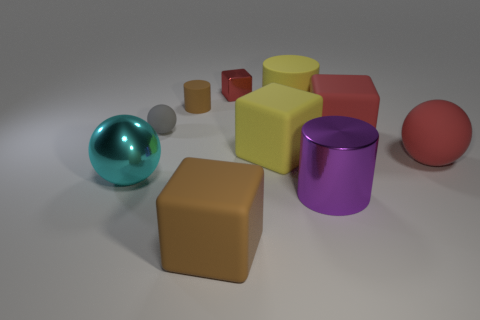Does the tiny metallic object have the same color as the big block right of the big rubber cylinder?
Offer a very short reply. Yes. Is there a cylinder that has the same material as the tiny red thing?
Your answer should be compact. Yes. The other rubber thing that is the same shape as the tiny brown object is what color?
Your answer should be compact. Yellow. Is the number of gray rubber objects in front of the red matte cube less than the number of rubber blocks to the right of the large purple metal cylinder?
Your response must be concise. Yes. How many other objects are there of the same shape as the cyan thing?
Give a very brief answer. 2. Is the number of shiny objects that are on the left side of the big metal cylinder less than the number of big things?
Your response must be concise. Yes. There is a big cylinder that is behind the large metallic cylinder; what material is it?
Keep it short and to the point. Rubber. What number of other things are there of the same size as the metal cylinder?
Provide a short and direct response. 6. Is the number of cyan rubber cylinders less than the number of big yellow rubber cylinders?
Give a very brief answer. Yes. What shape is the gray object?
Offer a very short reply. Sphere. 